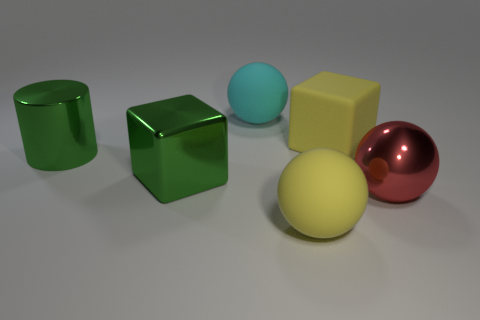Add 3 green cubes. How many objects exist? 9 Subtract all blocks. How many objects are left? 4 Subtract all large yellow matte cubes. Subtract all yellow things. How many objects are left? 3 Add 3 large metal things. How many large metal things are left? 6 Add 4 rubber blocks. How many rubber blocks exist? 5 Subtract 0 purple balls. How many objects are left? 6 